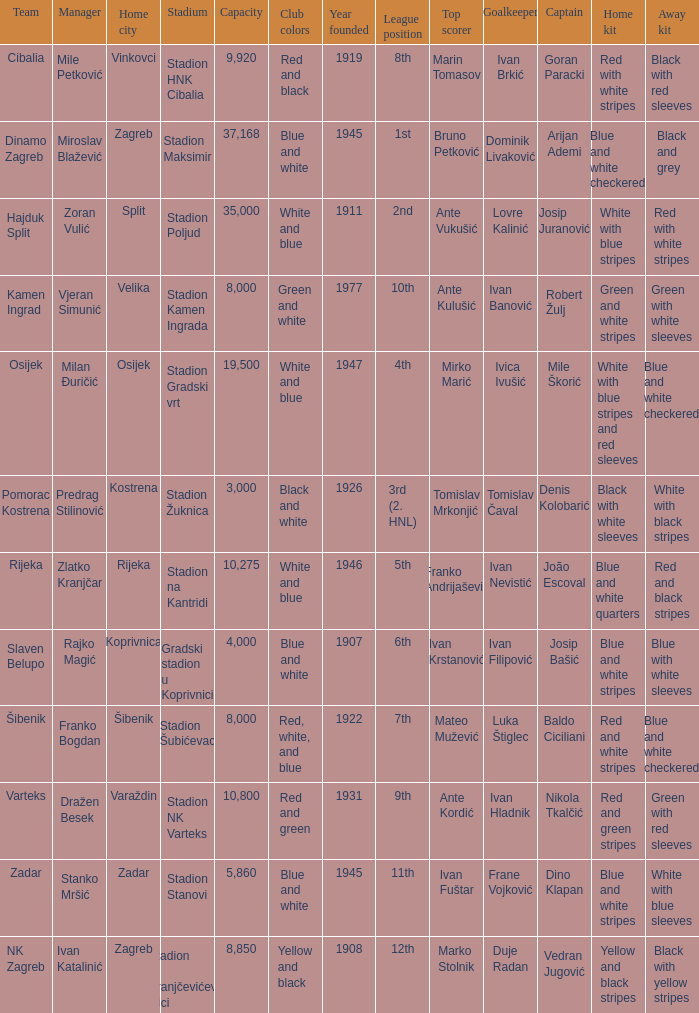What team has a home city of Koprivnica? Slaven Belupo. 